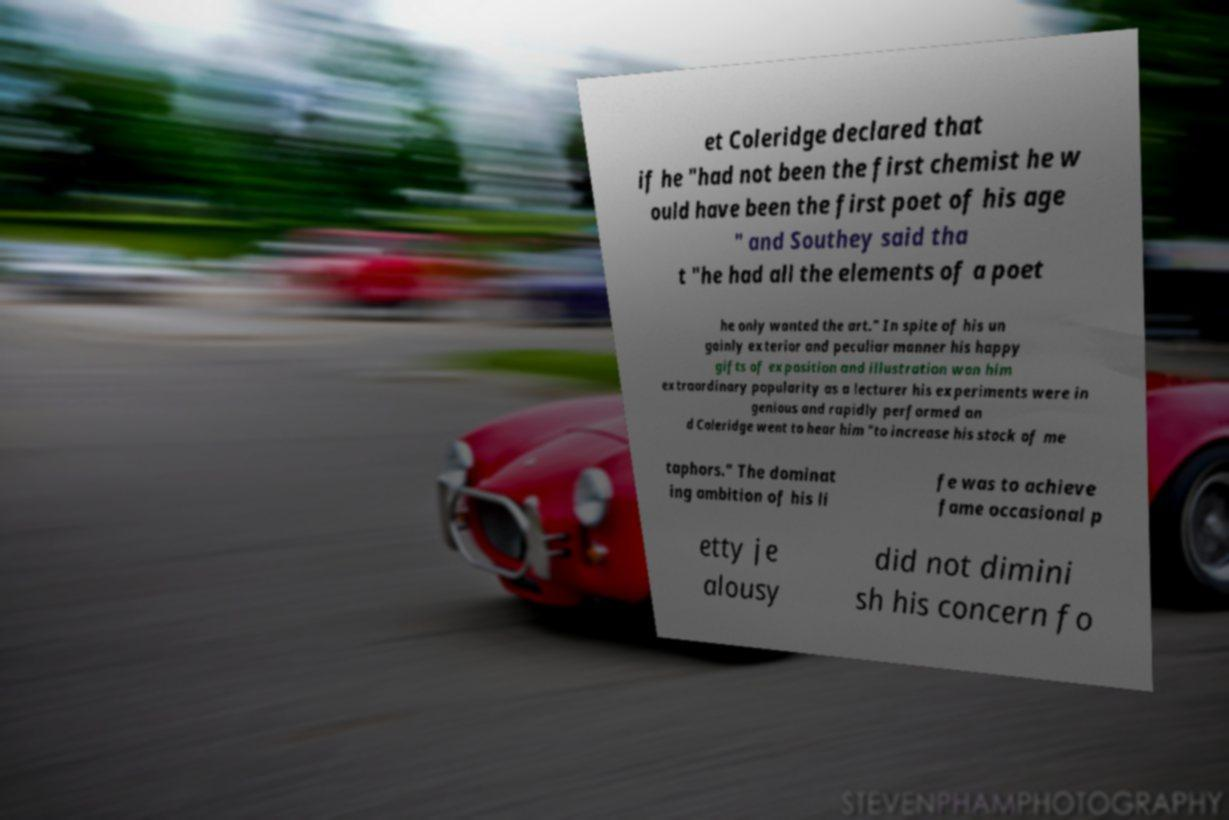Could you extract and type out the text from this image? et Coleridge declared that if he "had not been the first chemist he w ould have been the first poet of his age " and Southey said tha t "he had all the elements of a poet he only wanted the art." In spite of his un gainly exterior and peculiar manner his happy gifts of exposition and illustration won him extraordinary popularity as a lecturer his experiments were in genious and rapidly performed an d Coleridge went to hear him "to increase his stock of me taphors." The dominat ing ambition of his li fe was to achieve fame occasional p etty je alousy did not dimini sh his concern fo 